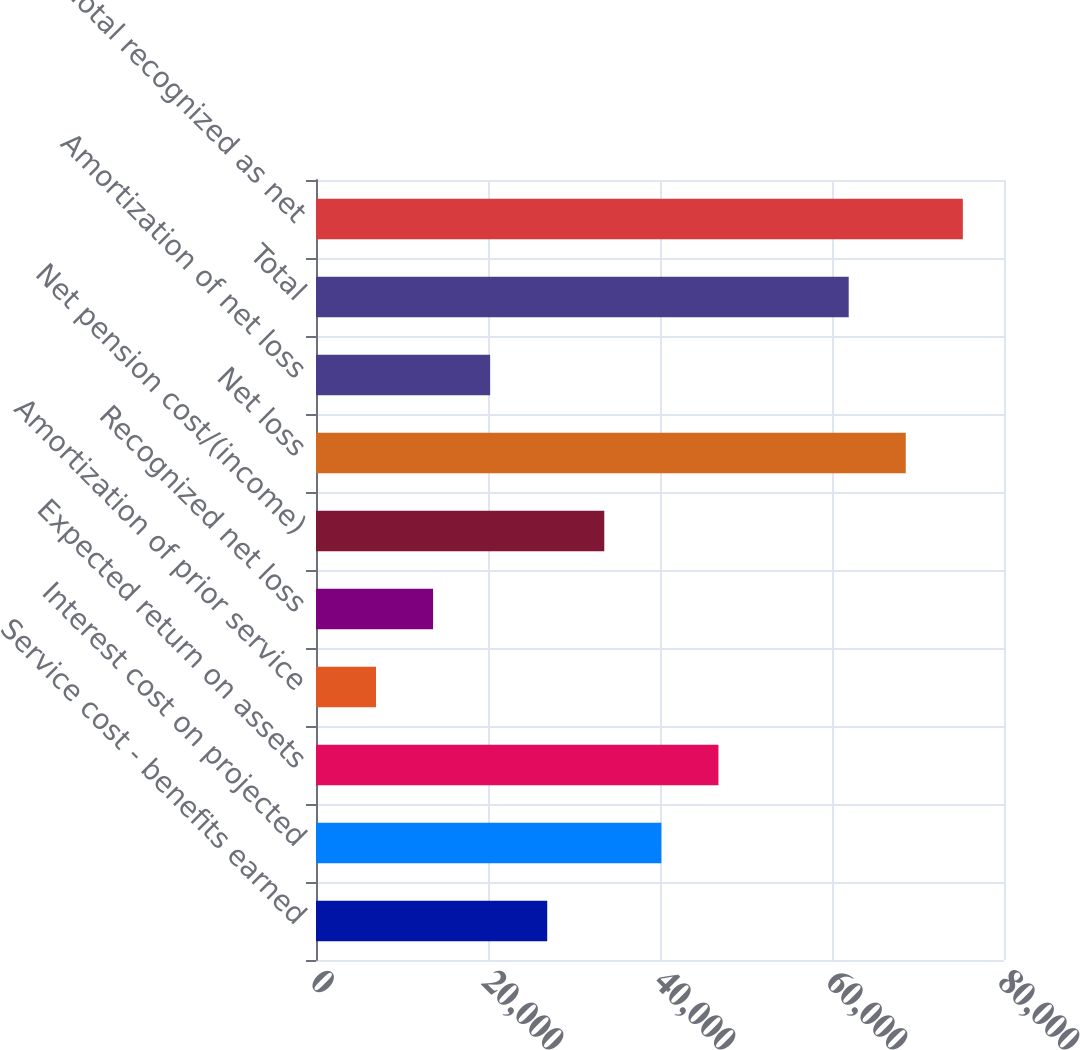<chart> <loc_0><loc_0><loc_500><loc_500><bar_chart><fcel>Service cost - benefits earned<fcel>Interest cost on projected<fcel>Expected return on assets<fcel>Amortization of prior service<fcel>Recognized net loss<fcel>Net pension cost/(income)<fcel>Net loss<fcel>Amortization of net loss<fcel>Total<fcel>Total recognized as net<nl><fcel>26886.2<fcel>40158.8<fcel>46795.1<fcel>6977.3<fcel>13613.6<fcel>33522.5<fcel>68579.3<fcel>20249.9<fcel>61943<fcel>75215.6<nl></chart> 